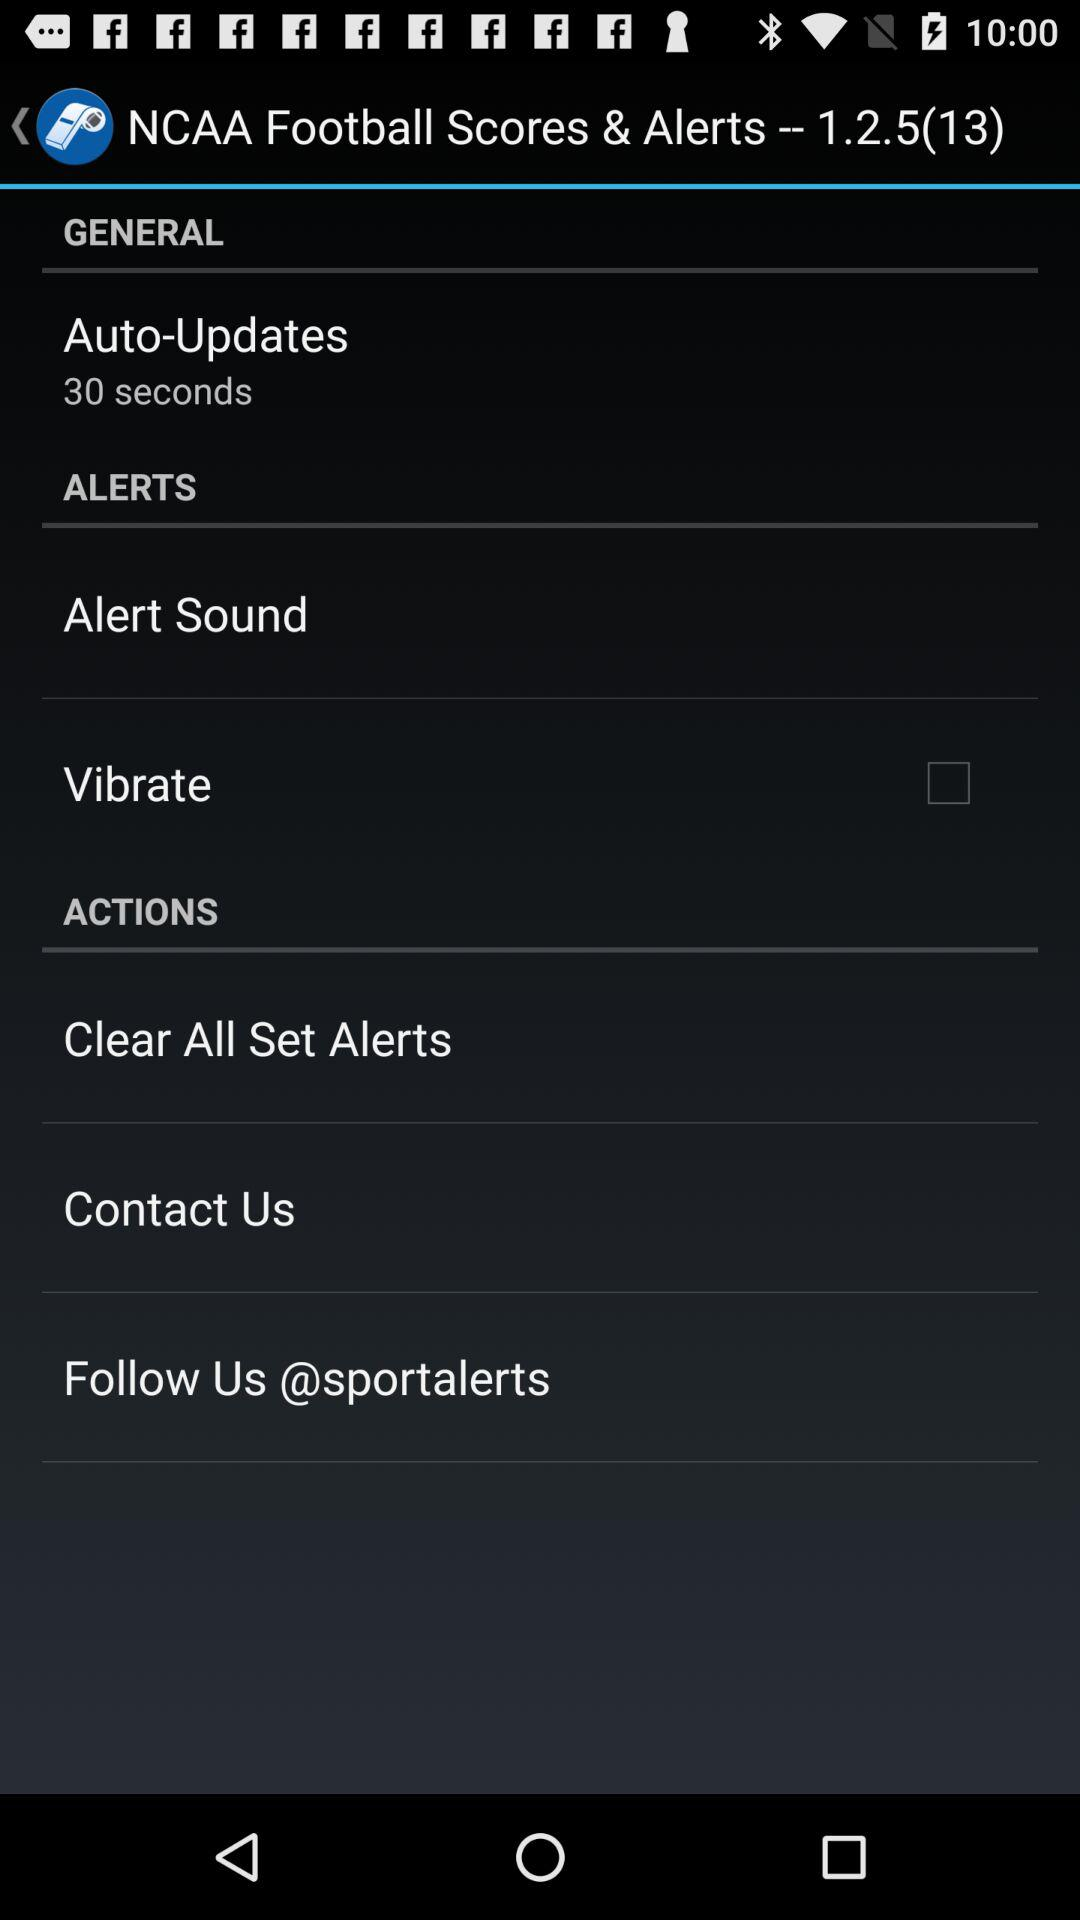What is the status of "Vibrate"? The status is "off". 